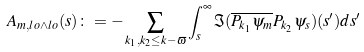Convert formula to latex. <formula><loc_0><loc_0><loc_500><loc_500>A _ { m , l o \wedge l o } ( s ) \colon = - \sum _ { k _ { 1 } , k _ { 2 } \leq k - \varpi } \int _ { s } ^ { \infty } \Im ( \overline { P _ { k _ { 1 } } \psi _ { m } } P _ { k _ { 2 } } \psi _ { s } ) ( s ^ { \prime } ) d s ^ { \prime }</formula> 